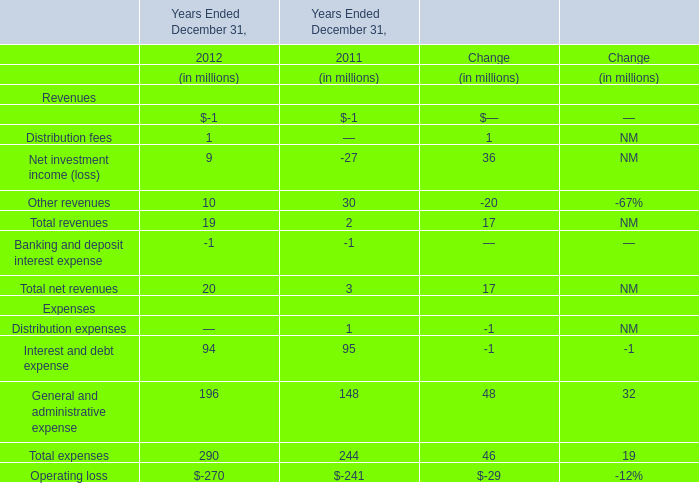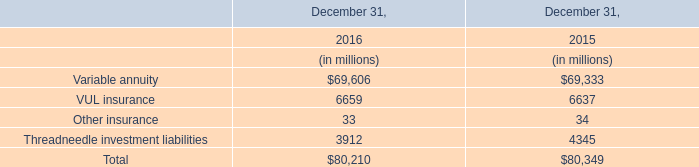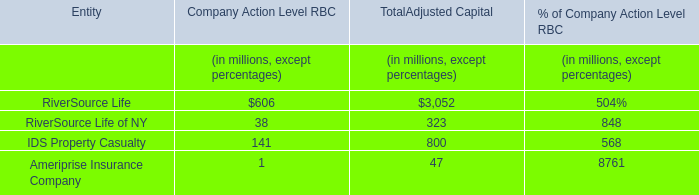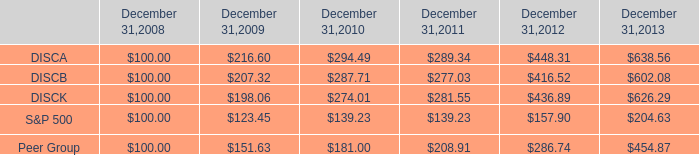What's the average of distribution fees and net investment income and other revenues in 2012? (in million) 
Computations: (((1 + 9) + 10) / 3)
Answer: 6.66667. 